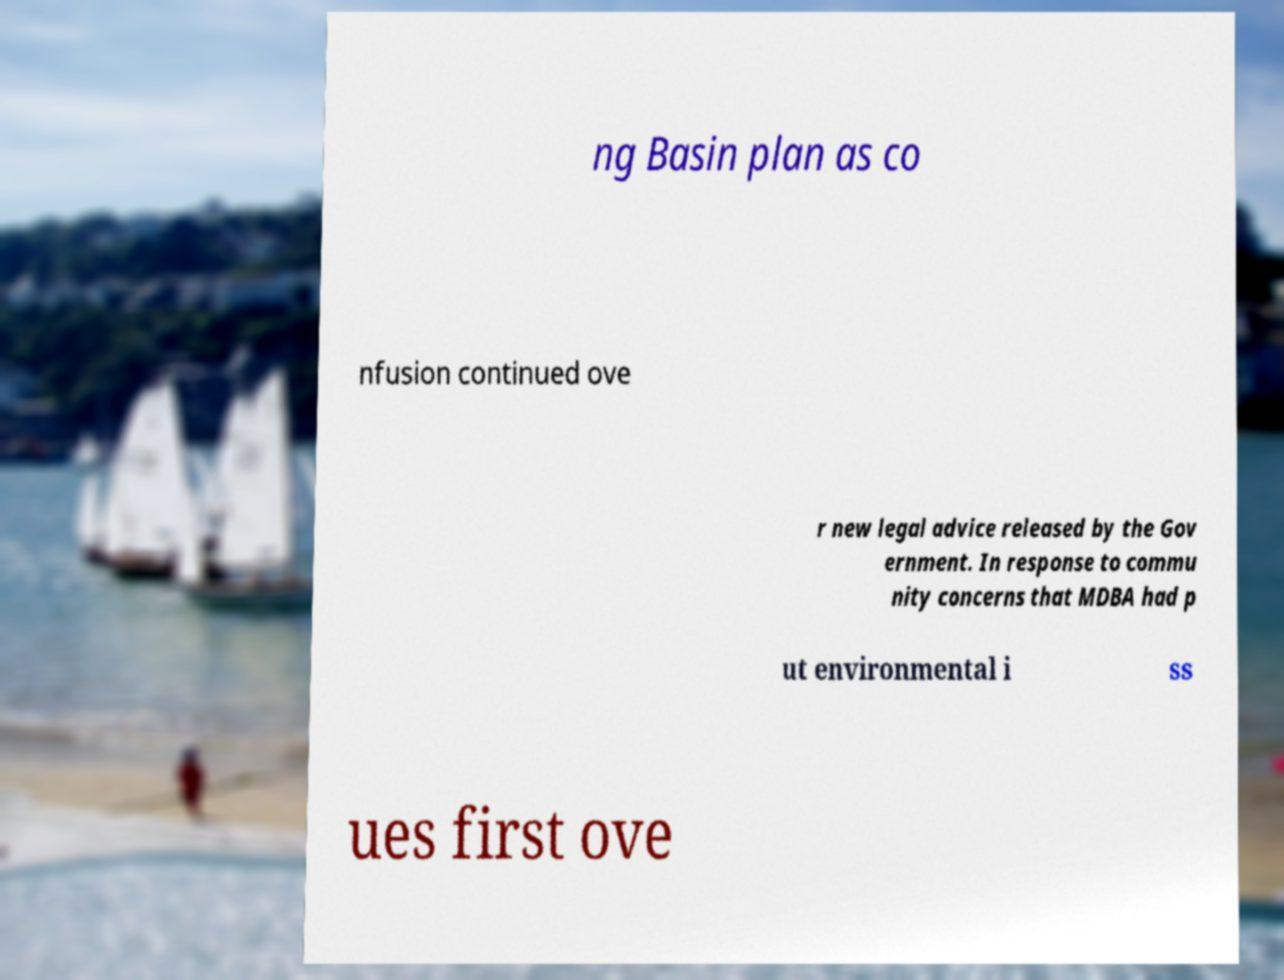Please read and relay the text visible in this image. What does it say? ng Basin plan as co nfusion continued ove r new legal advice released by the Gov ernment. In response to commu nity concerns that MDBA had p ut environmental i ss ues first ove 